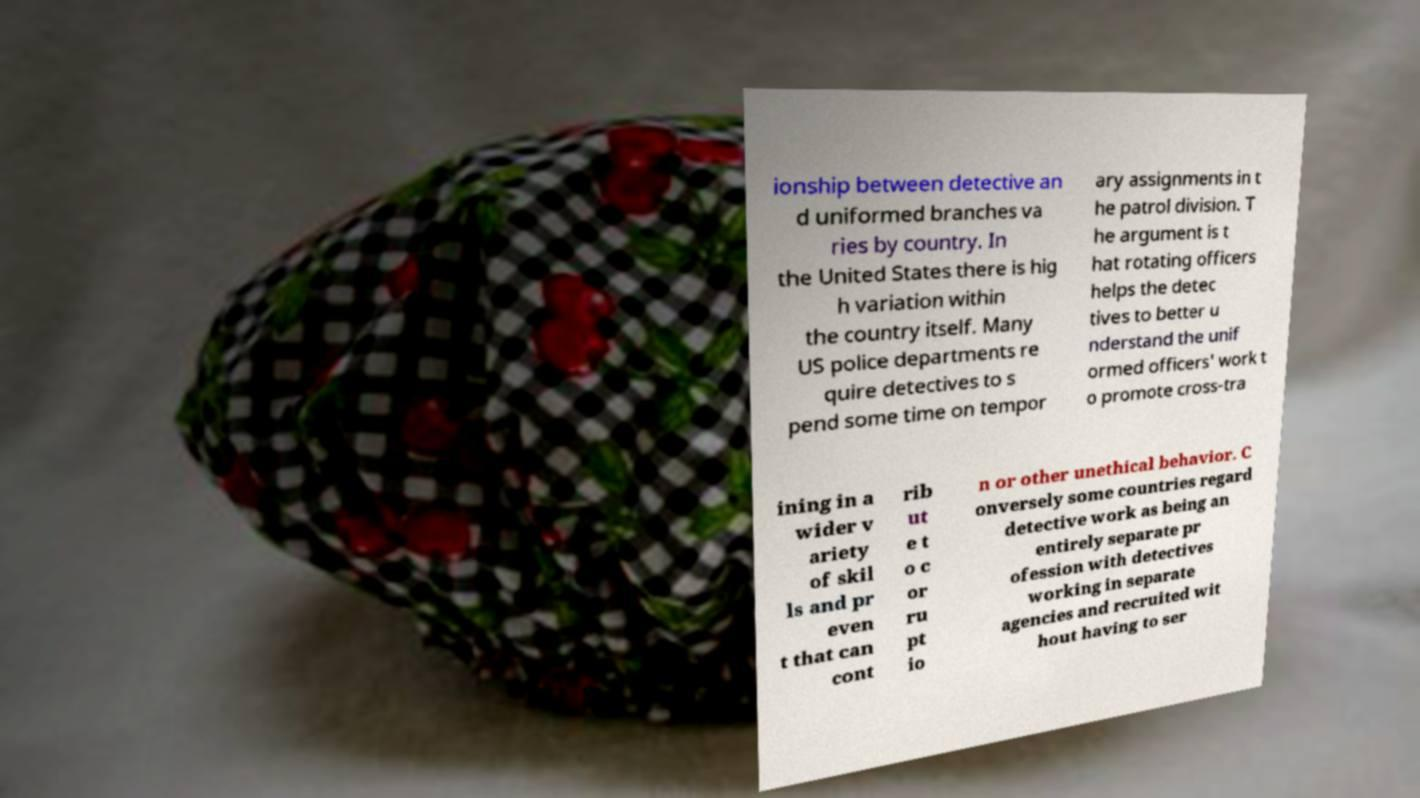Could you extract and type out the text from this image? ionship between detective an d uniformed branches va ries by country. In the United States there is hig h variation within the country itself. Many US police departments re quire detectives to s pend some time on tempor ary assignments in t he patrol division. T he argument is t hat rotating officers helps the detec tives to better u nderstand the unif ormed officers' work t o promote cross-tra ining in a wider v ariety of skil ls and pr even t that can cont rib ut e t o c or ru pt io n or other unethical behavior. C onversely some countries regard detective work as being an entirely separate pr ofession with detectives working in separate agencies and recruited wit hout having to ser 